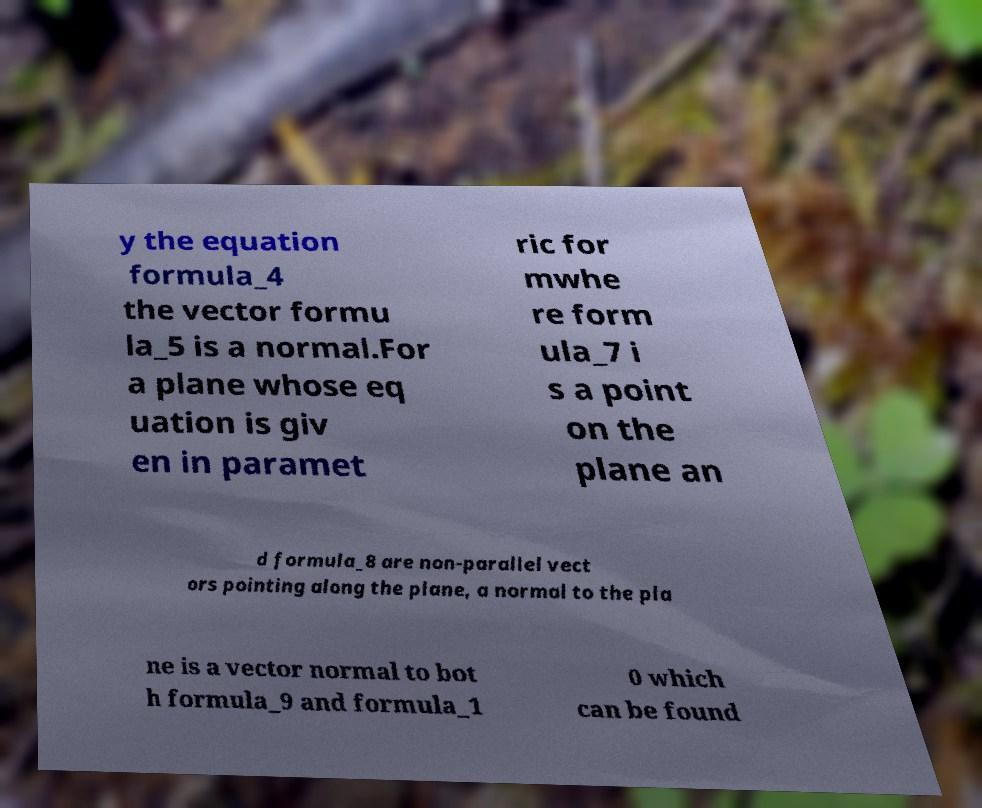Could you extract and type out the text from this image? y the equation formula_4 the vector formu la_5 is a normal.For a plane whose eq uation is giv en in paramet ric for mwhe re form ula_7 i s a point on the plane an d formula_8 are non-parallel vect ors pointing along the plane, a normal to the pla ne is a vector normal to bot h formula_9 and formula_1 0 which can be found 